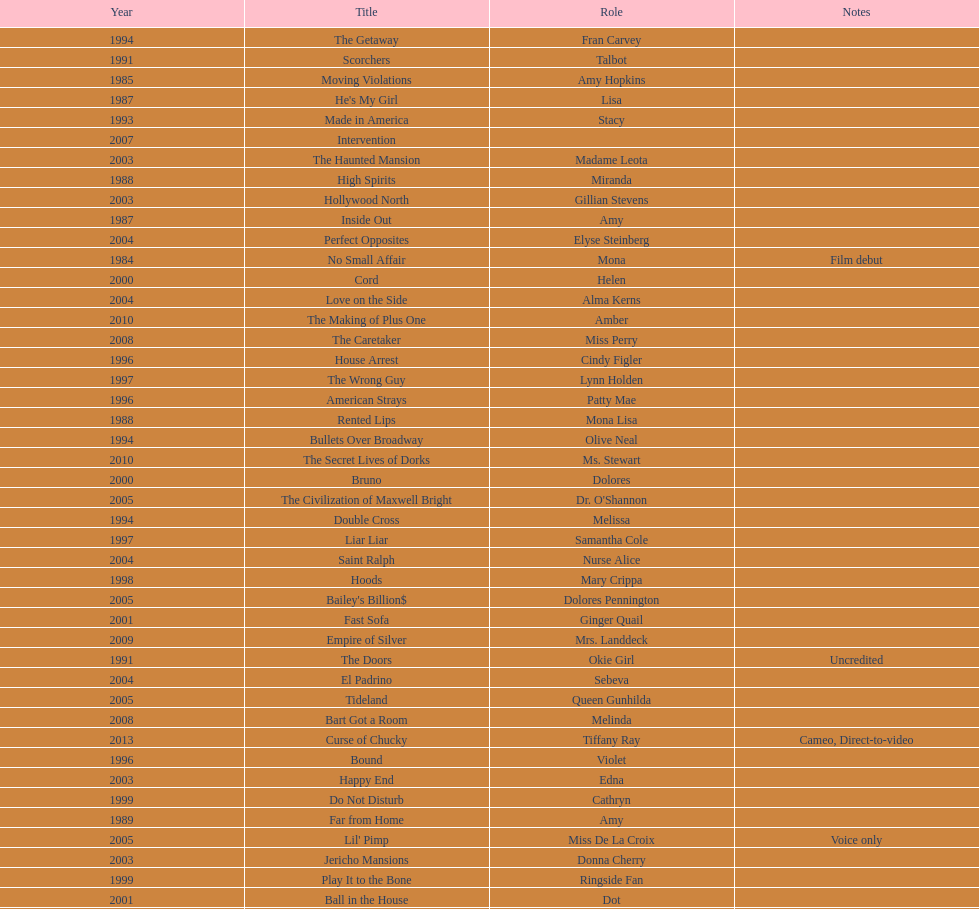How many movies does jennifer tilly play herself? 4. 